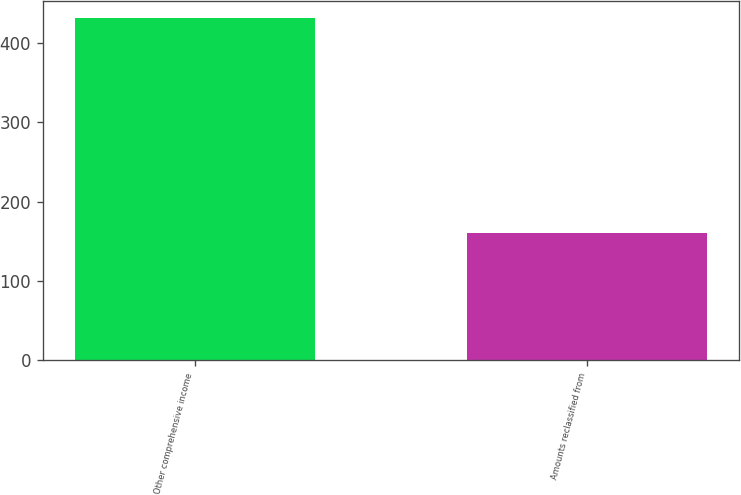Convert chart to OTSL. <chart><loc_0><loc_0><loc_500><loc_500><bar_chart><fcel>Other comprehensive income<fcel>Amounts reclassified from<nl><fcel>431<fcel>160<nl></chart> 